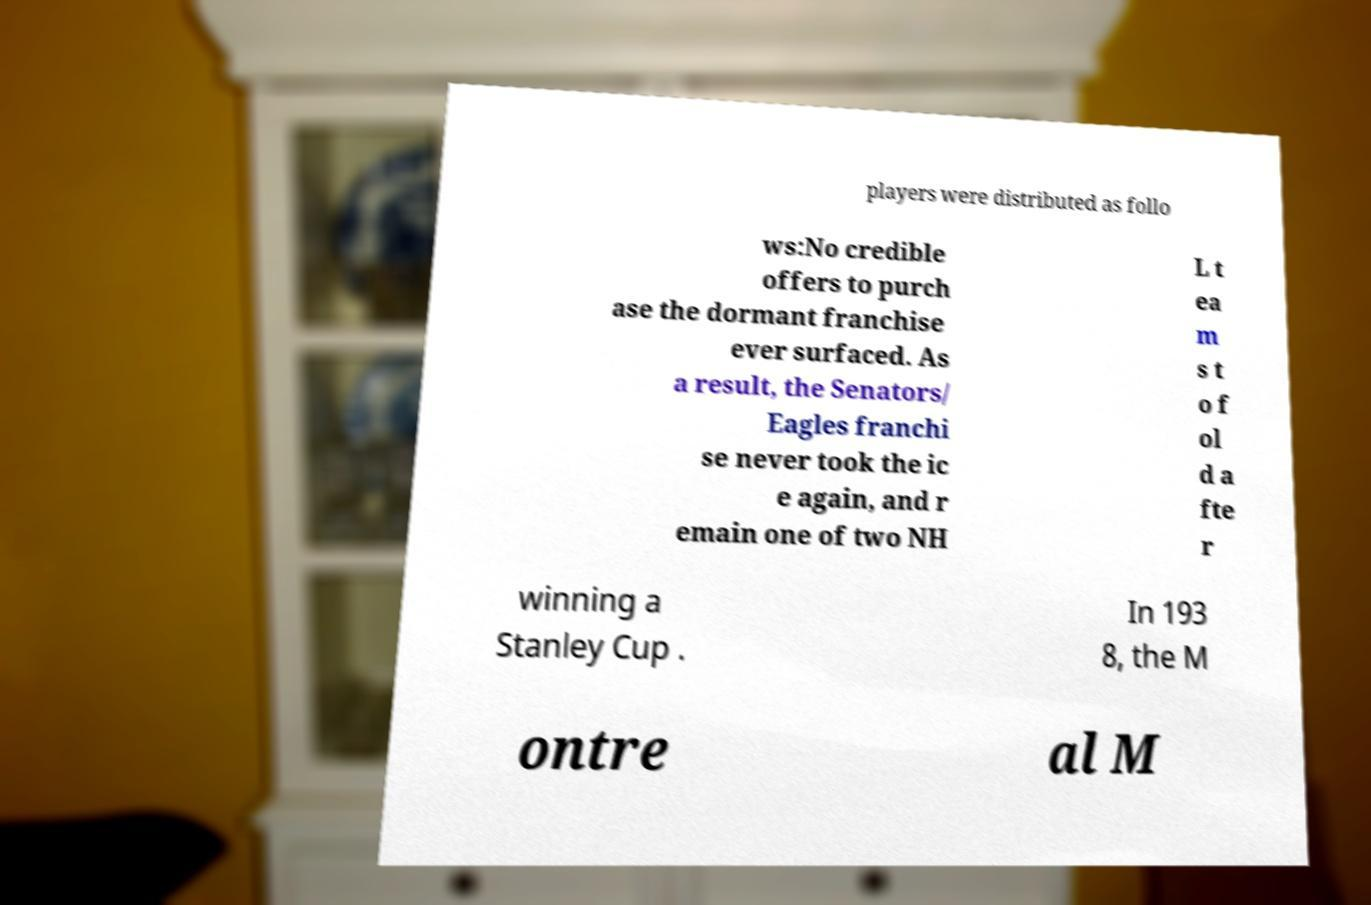Please read and relay the text visible in this image. What does it say? players were distributed as follo ws:No credible offers to purch ase the dormant franchise ever surfaced. As a result, the Senators/ Eagles franchi se never took the ic e again, and r emain one of two NH L t ea m s t o f ol d a fte r winning a Stanley Cup . In 193 8, the M ontre al M 